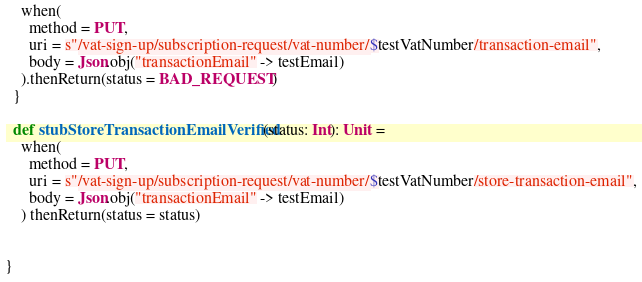Convert code to text. <code><loc_0><loc_0><loc_500><loc_500><_Scala_>    when(
      method = PUT,
      uri = s"/vat-sign-up/subscription-request/vat-number/$testVatNumber/transaction-email",
      body = Json.obj("transactionEmail" -> testEmail)
    ).thenReturn(status = BAD_REQUEST)
  }

  def stubStoreTransactionEmailVerified(status: Int): Unit =
    when(
      method = PUT,
      uri = s"/vat-sign-up/subscription-request/vat-number/$testVatNumber/store-transaction-email",
      body = Json.obj("transactionEmail" -> testEmail)
    ) thenReturn(status = status)


}</code> 